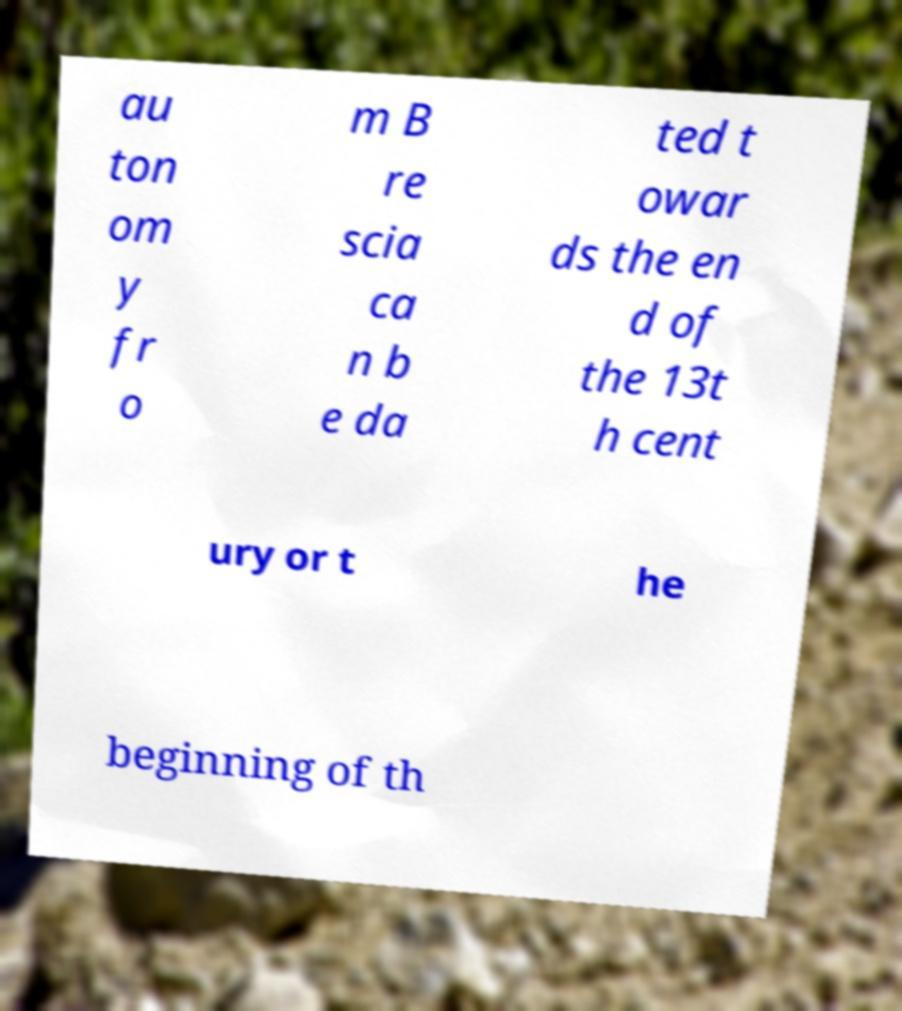Can you read and provide the text displayed in the image?This photo seems to have some interesting text. Can you extract and type it out for me? au ton om y fr o m B re scia ca n b e da ted t owar ds the en d of the 13t h cent ury or t he beginning of th 